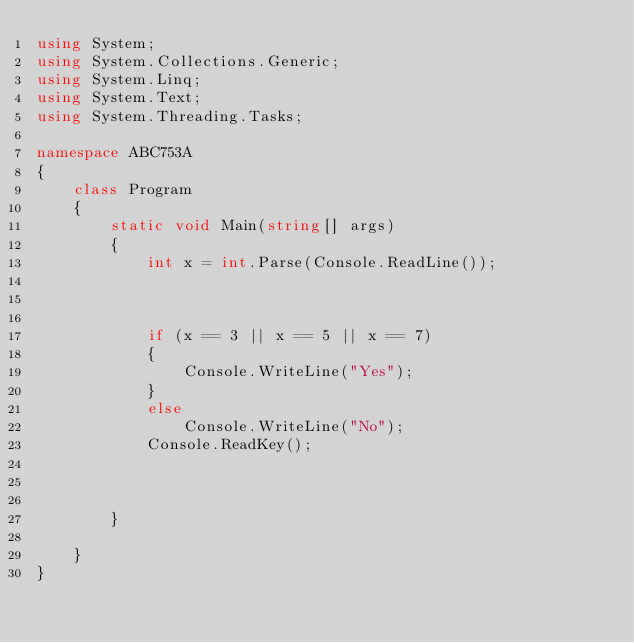Convert code to text. <code><loc_0><loc_0><loc_500><loc_500><_C#_>using System;
using System.Collections.Generic;
using System.Linq;
using System.Text;
using System.Threading.Tasks;

namespace ABC753A
{
    class Program
    {
        static void Main(string[] args)
        {
            int x = int.Parse(Console.ReadLine());
           
           

            if (x == 3 || x == 5 || x == 7)
            {
                Console.WriteLine("Yes");
            }
            else
                Console.WriteLine("No");
            Console.ReadKey();



        }

    }
}
</code> 